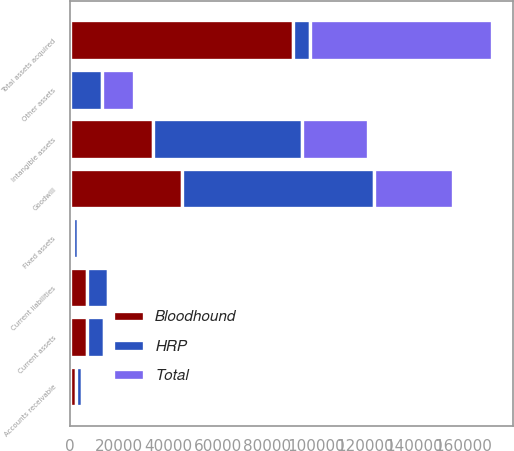Convert chart. <chart><loc_0><loc_0><loc_500><loc_500><stacked_bar_chart><ecel><fcel>Accounts receivable<fcel>Current assets<fcel>Fixed assets<fcel>Intangible assets<fcel>Goodwill<fcel>Other assets<fcel>Total assets acquired<fcel>Current liabilities<nl><fcel>Bloodhound<fcel>2278<fcel>6646<fcel>1091<fcel>33624<fcel>45635<fcel>16<fcel>90614<fcel>6869<nl><fcel>Total<fcel>378<fcel>297<fcel>1147<fcel>26871<fcel>32152<fcel>13000<fcel>73845<fcel>1445<nl><fcel>HRP<fcel>2656<fcel>6943<fcel>2238<fcel>60495<fcel>77787<fcel>13016<fcel>6943<fcel>8314<nl></chart> 